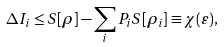<formula> <loc_0><loc_0><loc_500><loc_500>\Delta I _ { i } \leq S [ \rho ] - \sum _ { i } P _ { i } S [ \rho _ { i } ] \equiv \chi ( \varepsilon ) ,</formula> 